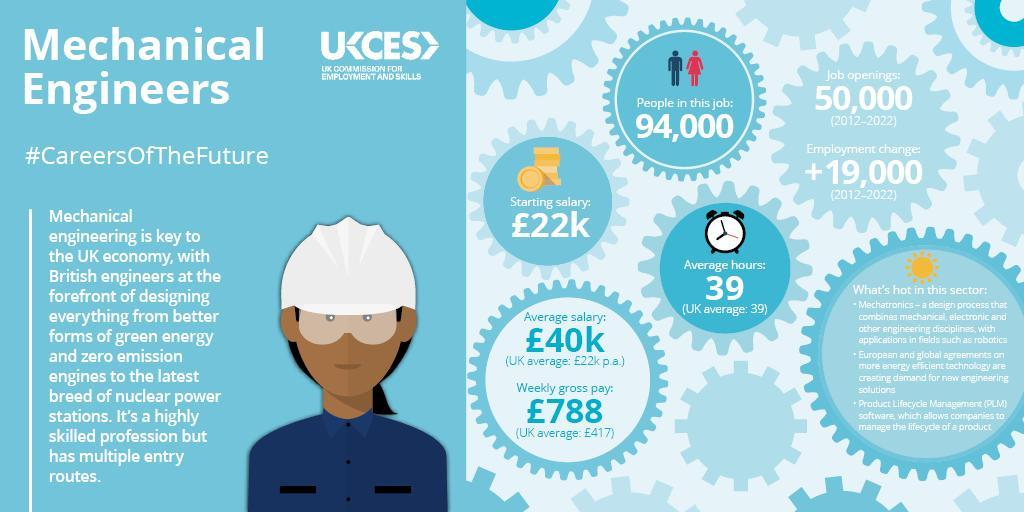What is the difference in average weekly gross pay for mechanical engineers while compared with the weekly gross pay for UK as a whole?
Answer the question with a short phrase. £371 What is the difference in average salary for mechanical engineers per annum while compared with the average salary for UK as a whole? £18k 